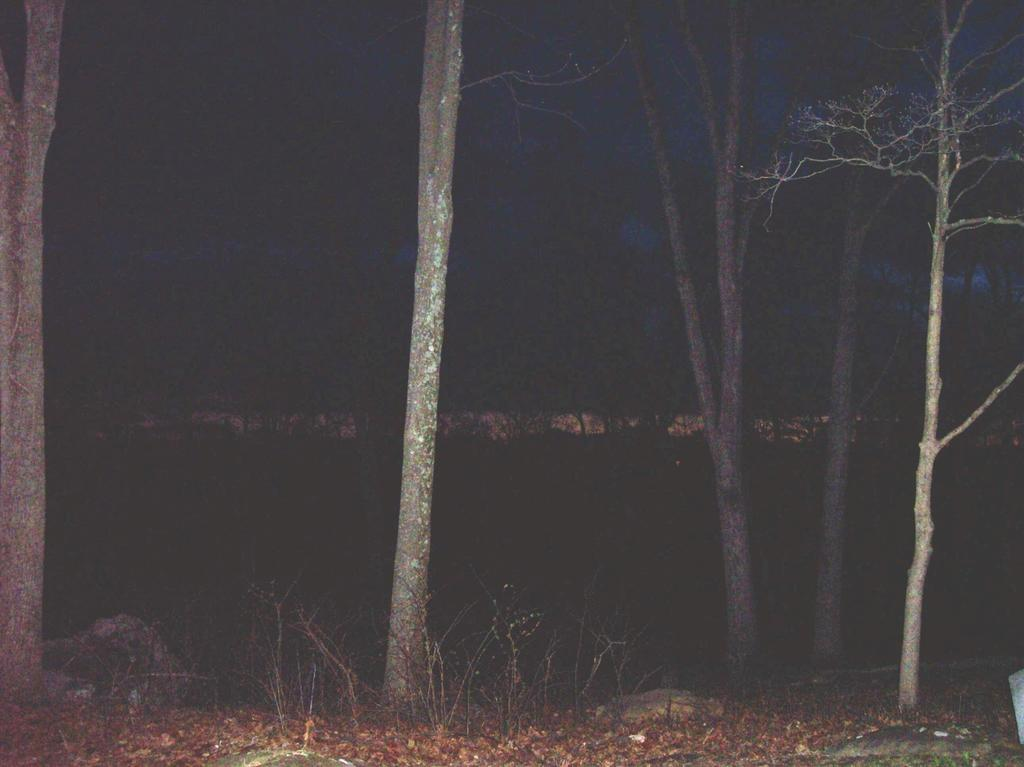What time of day is depicted in the image? The image depicts a night view. What type of vegetation can be seen in the image? There are many trees in the image. What is covering the ground in the image? There is grass on the ground in the image. Can you see a boy smiling in the image? There is no boy or smile present in the image. 